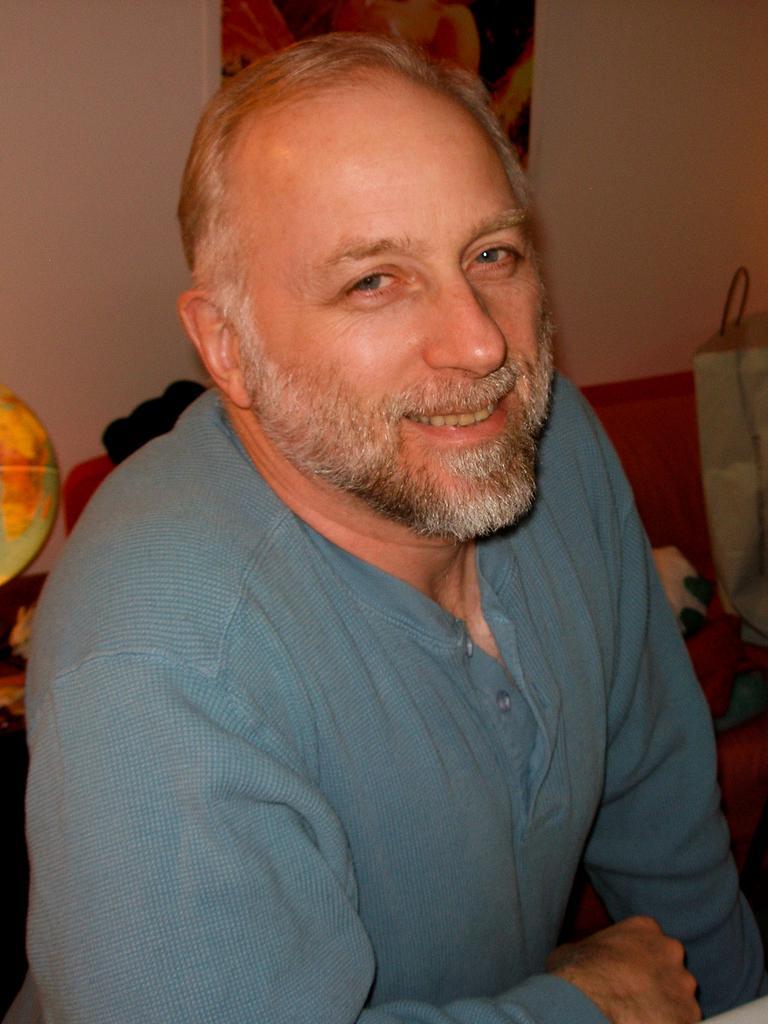Could you give a brief overview of what you see in this image? In this picture we can see a man is smiling. Behind the man there are some objects and wall. 